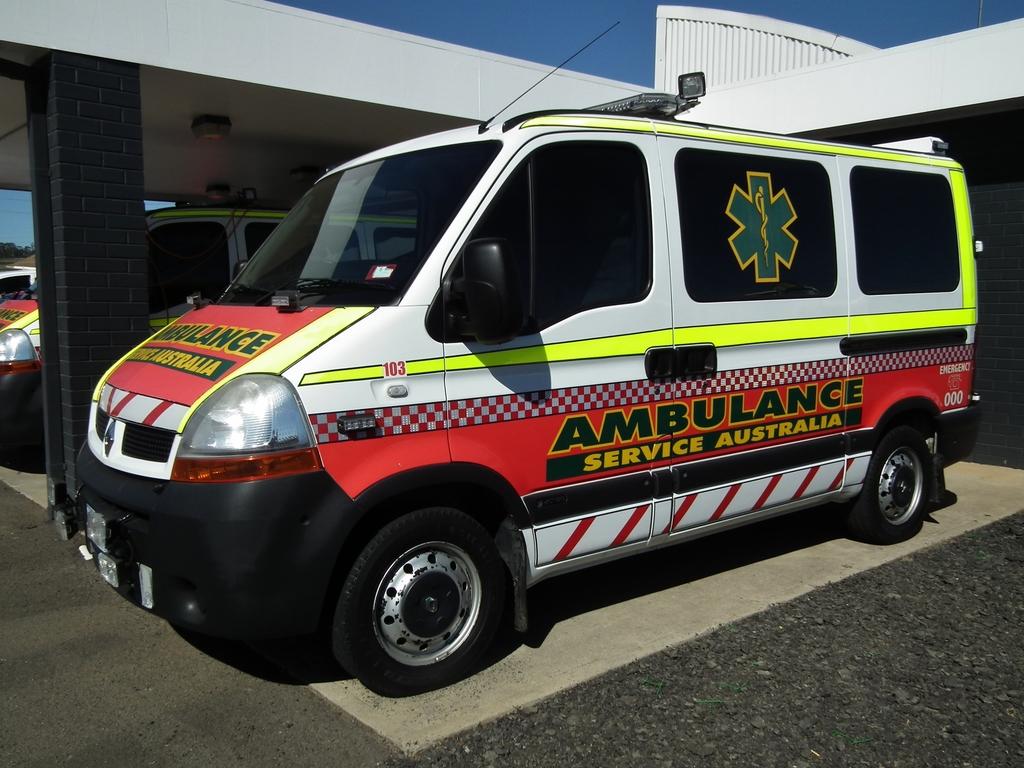Where is this ambulance?
Your answer should be very brief. Australia. What type of van is that shown?
Your answer should be compact. Ambulance. 